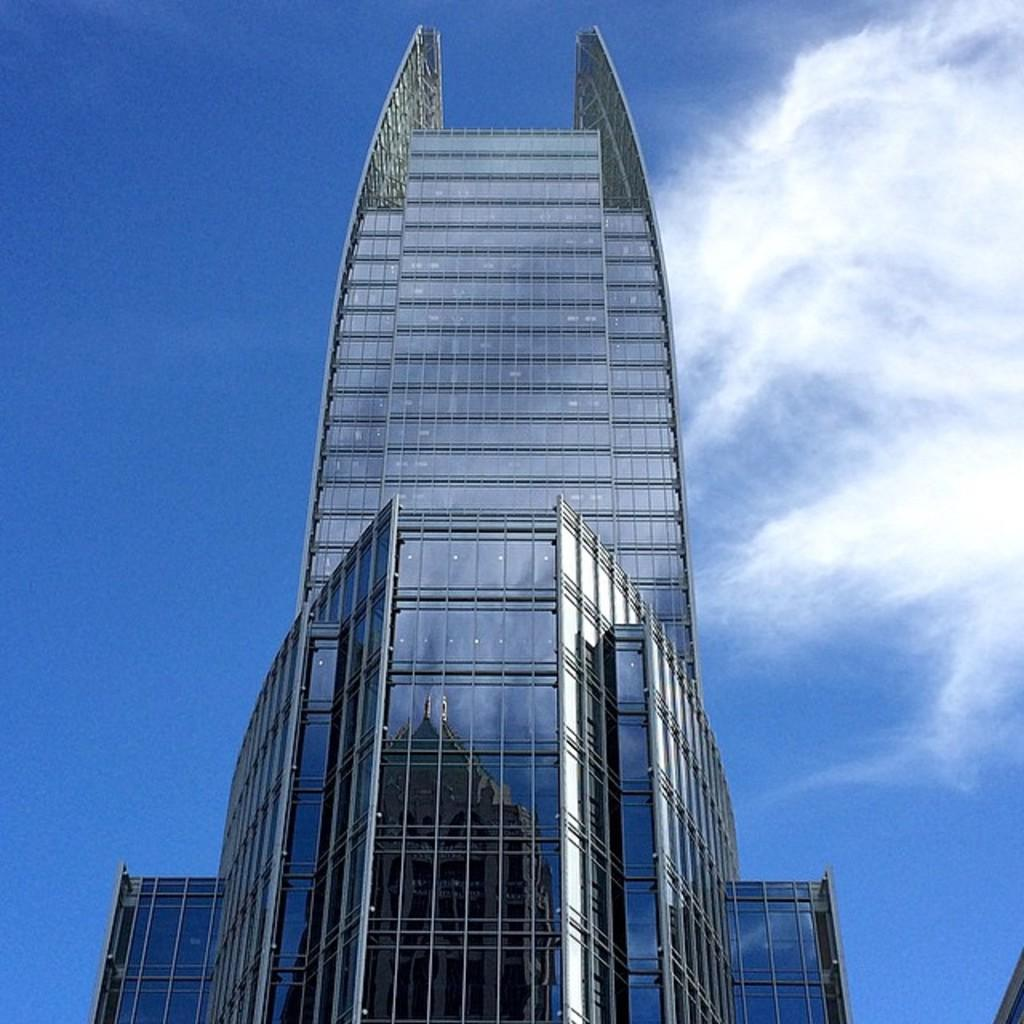What is the main structure in the middle of the image? There is a glass tower building in the middle of the image. What can be seen in the sky in the image? There are clouds in the sky. What type of government is depicted on the face of the building in the image? There is no face or representation of a government on the building in the image; it is a glass tower building. 